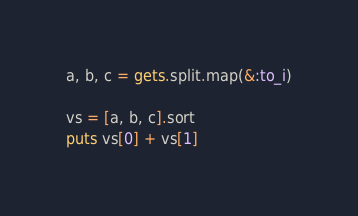Convert code to text. <code><loc_0><loc_0><loc_500><loc_500><_Ruby_>a, b, c = gets.split.map(&:to_i)

vs = [a, b, c].sort
puts vs[0] + vs[1]
</code> 